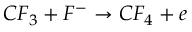<formula> <loc_0><loc_0><loc_500><loc_500>C F _ { 3 } + F ^ { - } \rightarrow C F _ { 4 } + e</formula> 